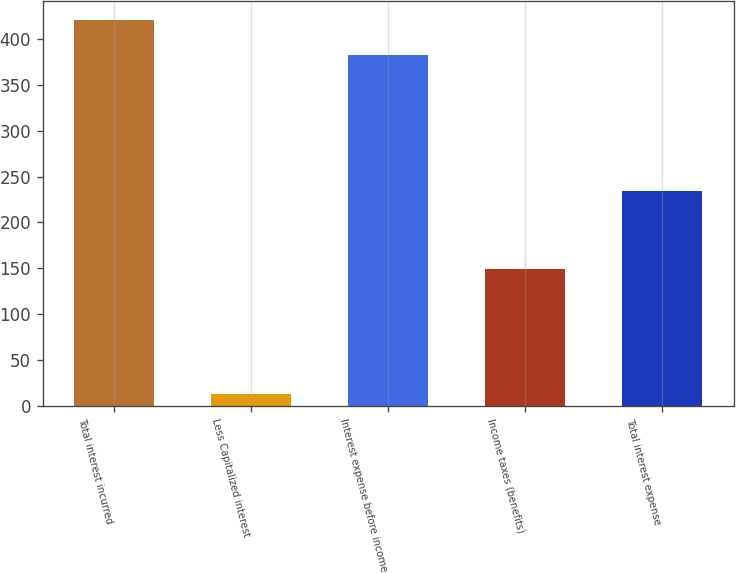<chart> <loc_0><loc_0><loc_500><loc_500><bar_chart><fcel>Total interest incurred<fcel>Less Capitalized interest<fcel>Interest expense before income<fcel>Income taxes (benefits)<fcel>Total interest expense<nl><fcel>421.3<fcel>13<fcel>383<fcel>149<fcel>234<nl></chart> 